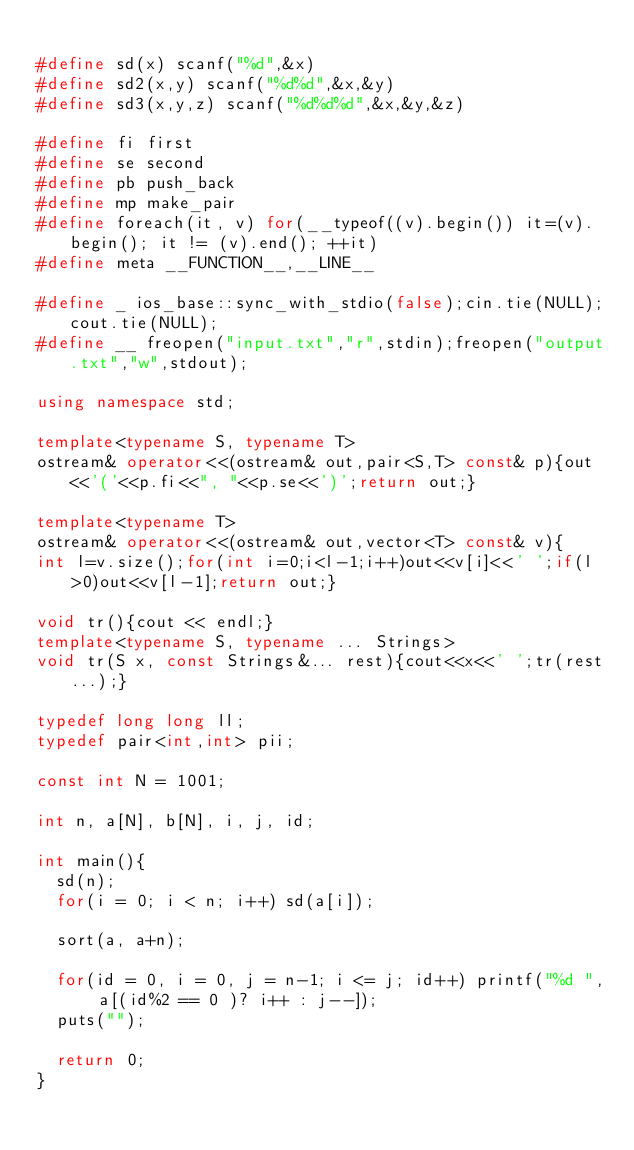Convert code to text. <code><loc_0><loc_0><loc_500><loc_500><_C++_>
#define sd(x) scanf("%d",&x)
#define sd2(x,y) scanf("%d%d",&x,&y)
#define sd3(x,y,z) scanf("%d%d%d",&x,&y,&z)

#define fi first
#define se second
#define pb push_back
#define mp make_pair
#define foreach(it, v) for(__typeof((v).begin()) it=(v).begin(); it != (v).end(); ++it)
#define meta __FUNCTION__,__LINE__

#define _ ios_base::sync_with_stdio(false);cin.tie(NULL);cout.tie(NULL);
#define __ freopen("input.txt","r",stdin);freopen("output.txt","w",stdout);

using namespace std;

template<typename S, typename T> 
ostream& operator<<(ostream& out,pair<S,T> const& p){out<<'('<<p.fi<<", "<<p.se<<')';return out;}

template<typename T>
ostream& operator<<(ostream& out,vector<T> const& v){
int l=v.size();for(int i=0;i<l-1;i++)out<<v[i]<<' ';if(l>0)out<<v[l-1];return out;}

void tr(){cout << endl;}
template<typename S, typename ... Strings>
void tr(S x, const Strings&... rest){cout<<x<<' ';tr(rest...);}

typedef long long ll;
typedef pair<int,int> pii;

const int N = 1001;

int n, a[N], b[N], i, j, id;

int main(){
	sd(n);
	for(i = 0; i < n; i++) sd(a[i]);
	
	sort(a, a+n);
	
	for(id = 0, i = 0, j = n-1; i <= j; id++) printf("%d ", a[(id%2 == 0 )? i++ : j--]);
	puts("");
	
	return 0;
}
</code> 